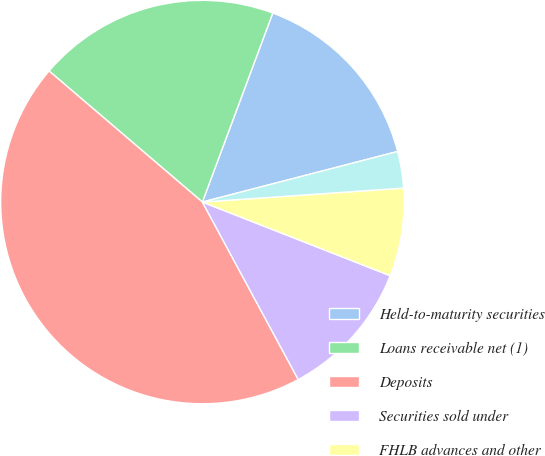<chart> <loc_0><loc_0><loc_500><loc_500><pie_chart><fcel>Held-to-maturity securities<fcel>Loans receivable net (1)<fcel>Deposits<fcel>Securities sold under<fcel>FHLB advances and other<fcel>Corporate debt<nl><fcel>15.29%<fcel>19.41%<fcel>44.13%<fcel>11.17%<fcel>7.05%<fcel>2.93%<nl></chart> 